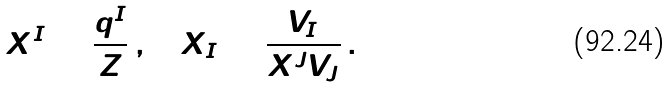<formula> <loc_0><loc_0><loc_500><loc_500>X ^ { I } = \frac { q ^ { I } } { Z } \, , \quad X _ { I } = \frac { V _ { I } } { X ^ { J } V _ { J } } \, .</formula> 